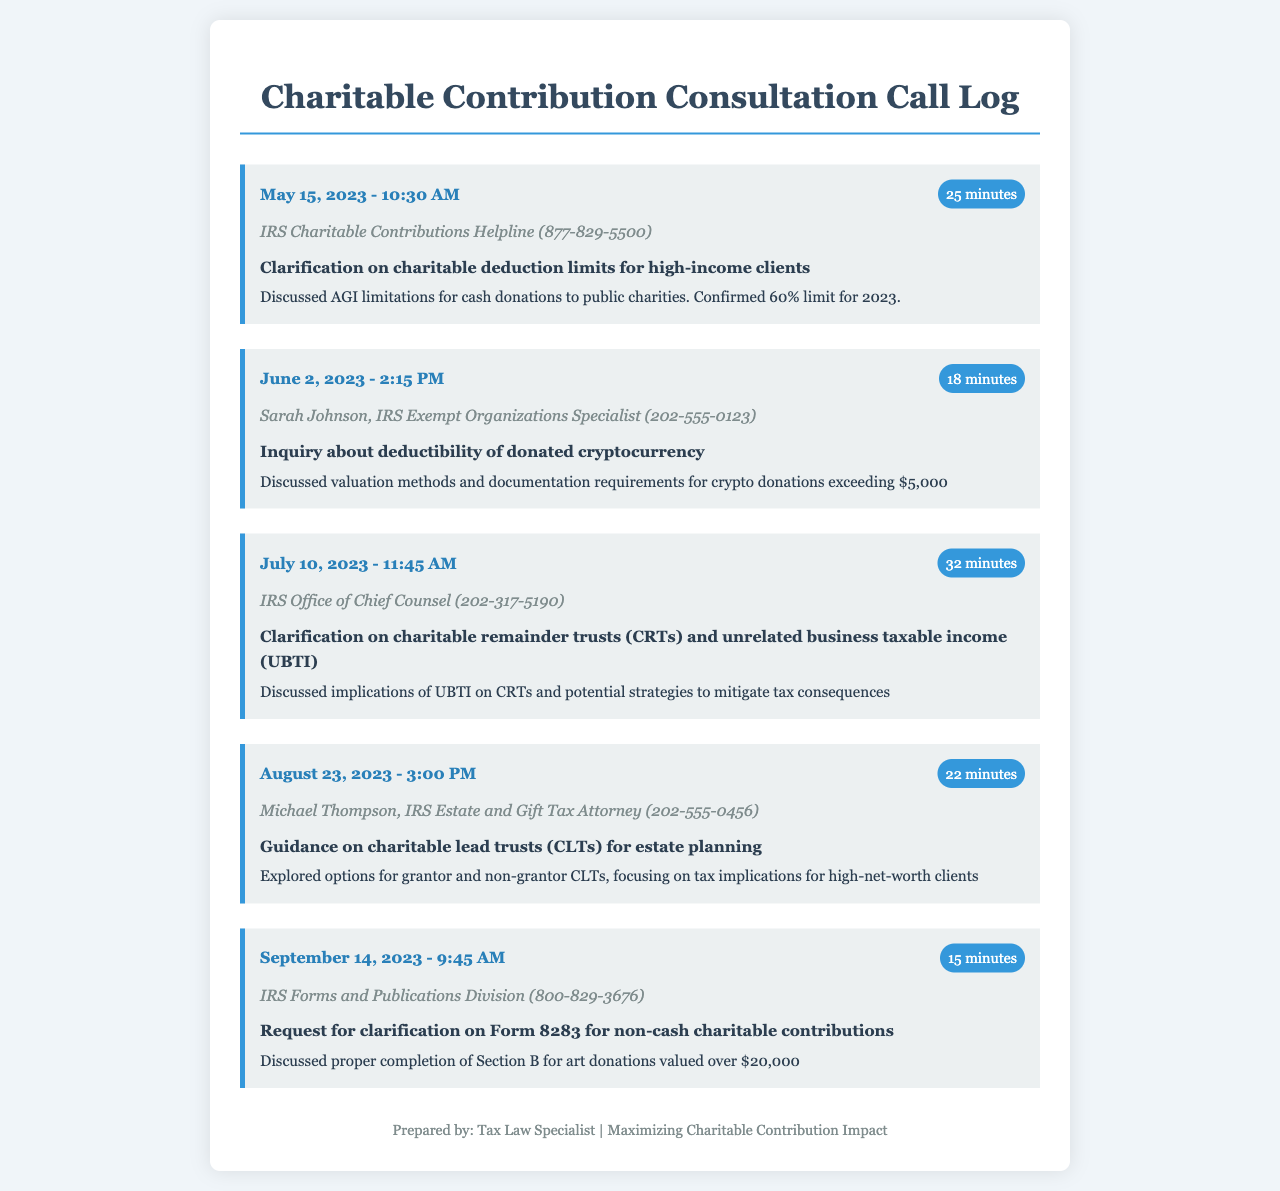What date was the call regarding charitable deduction limits? The call regarding charitable deduction limits took place on May 15, 2023.
Answer: May 15, 2023 Who did the call about cryptocurrency donations reach? The call about cryptocurrency donations was with Sarah Johnson, IRS Exempt Organizations Specialist.
Answer: Sarah Johnson How long was the call about charitable remainder trusts? The duration of the call about charitable remainder trusts was 32 minutes.
Answer: 32 minutes What was the main topic discussed on September 14, 2023? The main topic discussed on September 14, 2023, was Form 8283 for non-cash charitable contributions.
Answer: Form 8283 for non-cash charitable contributions What is the maximum deductible percentage for cash donations in 2023? The maximum deductible percentage for cash donations in 2023 is 60%.
Answer: 60% Who was the IRS contact during the call about charitable lead trusts? The IRS contact during the call about charitable lead trusts was Michael Thompson.
Answer: Michael Thompson What was the purpose of the call on June 2, 2023? The purpose of the call on June 2, 2023, was to inquire about the deductibility of donated cryptocurrency.
Answer: Deductibility of donated cryptocurrency How many minutes long was the call about non-cash charitable contributions? The call about non-cash charitable contributions lasted for 15 minutes.
Answer: 15 minutes What was discussed in relation to charitable remainder trusts? The discussion regarding charitable remainder trusts focused on implications of UBTI and tax mitigation strategies.
Answer: UBTI and tax mitigation strategies 